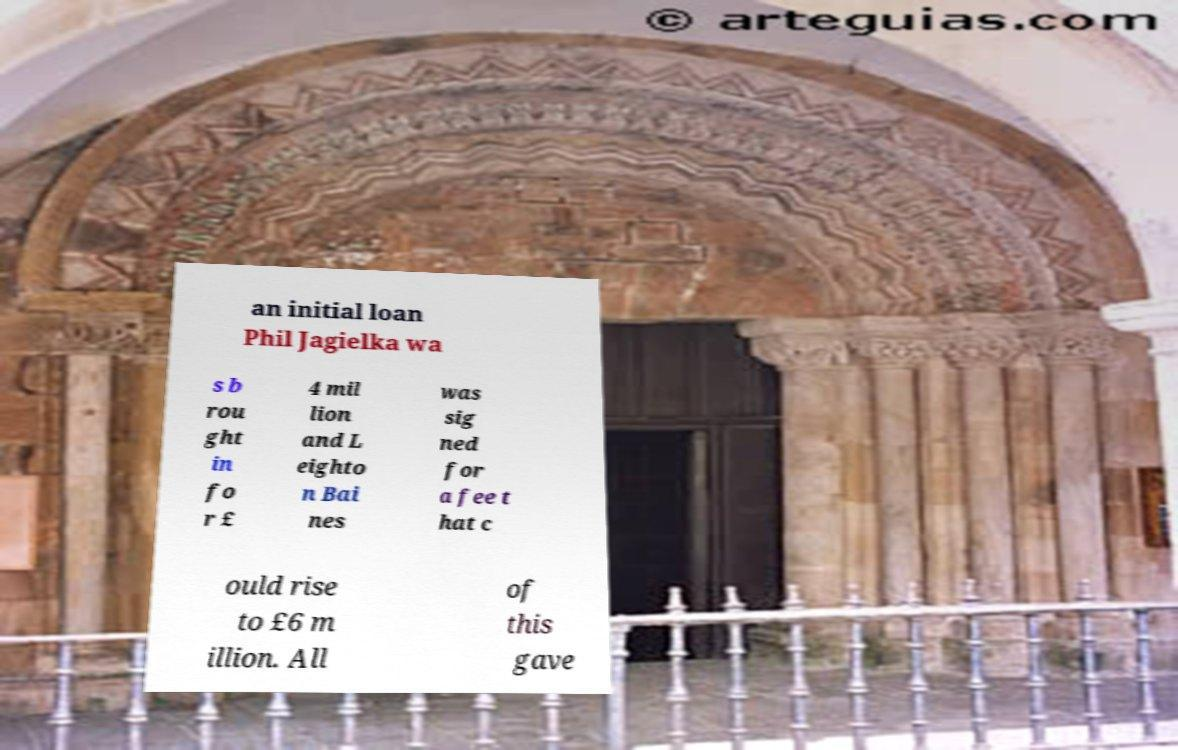Could you extract and type out the text from this image? an initial loan Phil Jagielka wa s b rou ght in fo r £ 4 mil lion and L eighto n Bai nes was sig ned for a fee t hat c ould rise to £6 m illion. All of this gave 